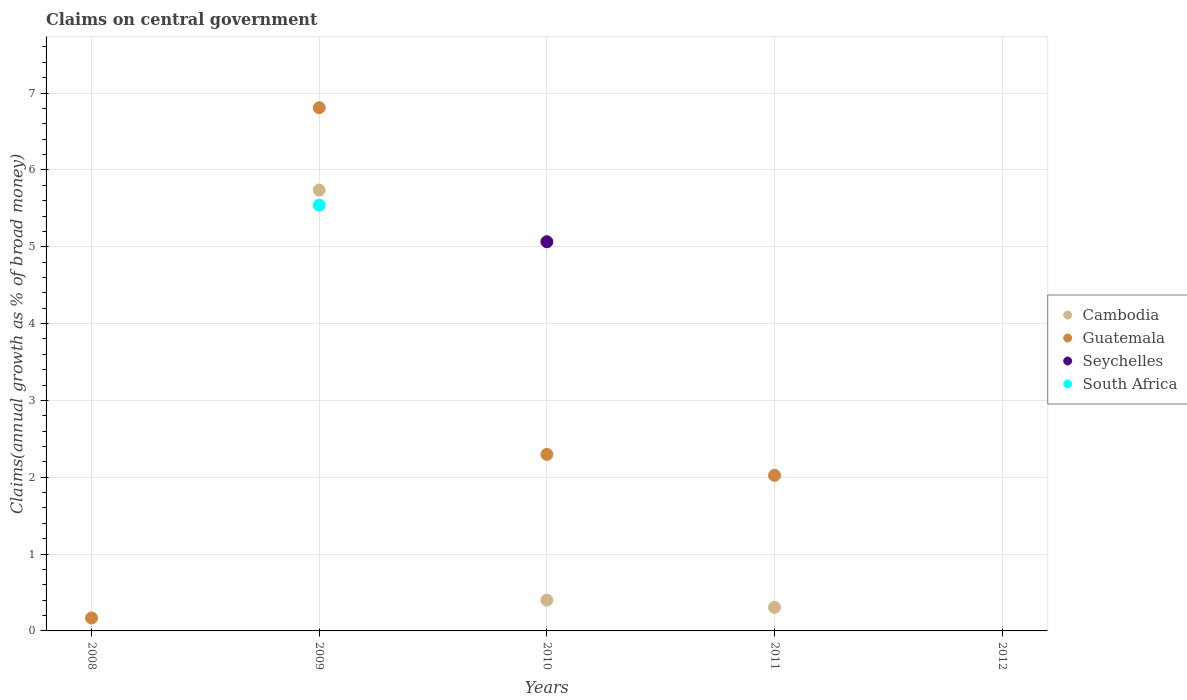How many different coloured dotlines are there?
Provide a succinct answer. 4. What is the percentage of broad money claimed on centeral government in Seychelles in 2009?
Make the answer very short. 0. Across all years, what is the maximum percentage of broad money claimed on centeral government in Guatemala?
Provide a short and direct response. 6.81. Across all years, what is the minimum percentage of broad money claimed on centeral government in South Africa?
Your response must be concise. 0. What is the total percentage of broad money claimed on centeral government in Seychelles in the graph?
Offer a very short reply. 5.07. What is the difference between the percentage of broad money claimed on centeral government in Cambodia in 2010 and that in 2011?
Your answer should be compact. 0.09. What is the difference between the percentage of broad money claimed on centeral government in Seychelles in 2011 and the percentage of broad money claimed on centeral government in Cambodia in 2012?
Provide a short and direct response. 0. What is the average percentage of broad money claimed on centeral government in Cambodia per year?
Provide a short and direct response. 1.29. In the year 2010, what is the difference between the percentage of broad money claimed on centeral government in Guatemala and percentage of broad money claimed on centeral government in Seychelles?
Provide a short and direct response. -2.77. In how many years, is the percentage of broad money claimed on centeral government in Guatemala greater than 0.2 %?
Your response must be concise. 3. What is the ratio of the percentage of broad money claimed on centeral government in Guatemala in 2009 to that in 2010?
Give a very brief answer. 2.96. What is the difference between the highest and the second highest percentage of broad money claimed on centeral government in Cambodia?
Your answer should be compact. 5.34. What is the difference between the highest and the lowest percentage of broad money claimed on centeral government in Cambodia?
Offer a very short reply. 5.74. Is it the case that in every year, the sum of the percentage of broad money claimed on centeral government in Seychelles and percentage of broad money claimed on centeral government in Guatemala  is greater than the sum of percentage of broad money claimed on centeral government in South Africa and percentage of broad money claimed on centeral government in Cambodia?
Give a very brief answer. No. Is it the case that in every year, the sum of the percentage of broad money claimed on centeral government in South Africa and percentage of broad money claimed on centeral government in Cambodia  is greater than the percentage of broad money claimed on centeral government in Seychelles?
Provide a succinct answer. No. Is the percentage of broad money claimed on centeral government in Seychelles strictly greater than the percentage of broad money claimed on centeral government in Cambodia over the years?
Keep it short and to the point. No. What is the difference between two consecutive major ticks on the Y-axis?
Your answer should be very brief. 1. Are the values on the major ticks of Y-axis written in scientific E-notation?
Your answer should be compact. No. Does the graph contain any zero values?
Provide a short and direct response. Yes. Where does the legend appear in the graph?
Your answer should be compact. Center right. How many legend labels are there?
Make the answer very short. 4. What is the title of the graph?
Provide a succinct answer. Claims on central government. What is the label or title of the Y-axis?
Ensure brevity in your answer.  Claims(annual growth as % of broad money). What is the Claims(annual growth as % of broad money) in Guatemala in 2008?
Ensure brevity in your answer.  0.17. What is the Claims(annual growth as % of broad money) of Cambodia in 2009?
Your answer should be compact. 5.74. What is the Claims(annual growth as % of broad money) in Guatemala in 2009?
Offer a terse response. 6.81. What is the Claims(annual growth as % of broad money) in Seychelles in 2009?
Provide a succinct answer. 0. What is the Claims(annual growth as % of broad money) of South Africa in 2009?
Give a very brief answer. 5.54. What is the Claims(annual growth as % of broad money) in Cambodia in 2010?
Offer a very short reply. 0.4. What is the Claims(annual growth as % of broad money) of Guatemala in 2010?
Offer a very short reply. 2.3. What is the Claims(annual growth as % of broad money) in Seychelles in 2010?
Ensure brevity in your answer.  5.07. What is the Claims(annual growth as % of broad money) in Cambodia in 2011?
Your answer should be very brief. 0.31. What is the Claims(annual growth as % of broad money) in Guatemala in 2011?
Keep it short and to the point. 2.03. What is the Claims(annual growth as % of broad money) of Seychelles in 2011?
Ensure brevity in your answer.  0. What is the Claims(annual growth as % of broad money) in Cambodia in 2012?
Give a very brief answer. 0. Across all years, what is the maximum Claims(annual growth as % of broad money) in Cambodia?
Your answer should be compact. 5.74. Across all years, what is the maximum Claims(annual growth as % of broad money) of Guatemala?
Your response must be concise. 6.81. Across all years, what is the maximum Claims(annual growth as % of broad money) of Seychelles?
Provide a short and direct response. 5.07. Across all years, what is the maximum Claims(annual growth as % of broad money) in South Africa?
Ensure brevity in your answer.  5.54. Across all years, what is the minimum Claims(annual growth as % of broad money) in Seychelles?
Offer a very short reply. 0. What is the total Claims(annual growth as % of broad money) of Cambodia in the graph?
Your answer should be compact. 6.45. What is the total Claims(annual growth as % of broad money) in Guatemala in the graph?
Your response must be concise. 11.3. What is the total Claims(annual growth as % of broad money) in Seychelles in the graph?
Your answer should be very brief. 5.07. What is the total Claims(annual growth as % of broad money) of South Africa in the graph?
Give a very brief answer. 5.54. What is the difference between the Claims(annual growth as % of broad money) in Guatemala in 2008 and that in 2009?
Give a very brief answer. -6.64. What is the difference between the Claims(annual growth as % of broad money) of Guatemala in 2008 and that in 2010?
Make the answer very short. -2.13. What is the difference between the Claims(annual growth as % of broad money) in Guatemala in 2008 and that in 2011?
Give a very brief answer. -1.86. What is the difference between the Claims(annual growth as % of broad money) in Cambodia in 2009 and that in 2010?
Your response must be concise. 5.34. What is the difference between the Claims(annual growth as % of broad money) of Guatemala in 2009 and that in 2010?
Provide a short and direct response. 4.51. What is the difference between the Claims(annual growth as % of broad money) of Cambodia in 2009 and that in 2011?
Keep it short and to the point. 5.43. What is the difference between the Claims(annual growth as % of broad money) of Guatemala in 2009 and that in 2011?
Offer a very short reply. 4.78. What is the difference between the Claims(annual growth as % of broad money) in Cambodia in 2010 and that in 2011?
Your response must be concise. 0.09. What is the difference between the Claims(annual growth as % of broad money) in Guatemala in 2010 and that in 2011?
Ensure brevity in your answer.  0.27. What is the difference between the Claims(annual growth as % of broad money) in Guatemala in 2008 and the Claims(annual growth as % of broad money) in South Africa in 2009?
Ensure brevity in your answer.  -5.37. What is the difference between the Claims(annual growth as % of broad money) in Guatemala in 2008 and the Claims(annual growth as % of broad money) in Seychelles in 2010?
Your response must be concise. -4.9. What is the difference between the Claims(annual growth as % of broad money) of Cambodia in 2009 and the Claims(annual growth as % of broad money) of Guatemala in 2010?
Give a very brief answer. 3.44. What is the difference between the Claims(annual growth as % of broad money) of Cambodia in 2009 and the Claims(annual growth as % of broad money) of Seychelles in 2010?
Ensure brevity in your answer.  0.67. What is the difference between the Claims(annual growth as % of broad money) in Guatemala in 2009 and the Claims(annual growth as % of broad money) in Seychelles in 2010?
Provide a succinct answer. 1.74. What is the difference between the Claims(annual growth as % of broad money) in Cambodia in 2009 and the Claims(annual growth as % of broad money) in Guatemala in 2011?
Give a very brief answer. 3.71. What is the difference between the Claims(annual growth as % of broad money) in Cambodia in 2010 and the Claims(annual growth as % of broad money) in Guatemala in 2011?
Give a very brief answer. -1.62. What is the average Claims(annual growth as % of broad money) of Cambodia per year?
Offer a very short reply. 1.29. What is the average Claims(annual growth as % of broad money) of Guatemala per year?
Your response must be concise. 2.26. What is the average Claims(annual growth as % of broad money) in Seychelles per year?
Make the answer very short. 1.01. What is the average Claims(annual growth as % of broad money) of South Africa per year?
Your response must be concise. 1.11. In the year 2009, what is the difference between the Claims(annual growth as % of broad money) of Cambodia and Claims(annual growth as % of broad money) of Guatemala?
Your answer should be very brief. -1.07. In the year 2009, what is the difference between the Claims(annual growth as % of broad money) of Cambodia and Claims(annual growth as % of broad money) of South Africa?
Make the answer very short. 0.2. In the year 2009, what is the difference between the Claims(annual growth as % of broad money) of Guatemala and Claims(annual growth as % of broad money) of South Africa?
Offer a terse response. 1.27. In the year 2010, what is the difference between the Claims(annual growth as % of broad money) of Cambodia and Claims(annual growth as % of broad money) of Guatemala?
Keep it short and to the point. -1.9. In the year 2010, what is the difference between the Claims(annual growth as % of broad money) of Cambodia and Claims(annual growth as % of broad money) of Seychelles?
Your answer should be compact. -4.67. In the year 2010, what is the difference between the Claims(annual growth as % of broad money) in Guatemala and Claims(annual growth as % of broad money) in Seychelles?
Ensure brevity in your answer.  -2.77. In the year 2011, what is the difference between the Claims(annual growth as % of broad money) of Cambodia and Claims(annual growth as % of broad money) of Guatemala?
Your response must be concise. -1.72. What is the ratio of the Claims(annual growth as % of broad money) in Guatemala in 2008 to that in 2009?
Provide a succinct answer. 0.02. What is the ratio of the Claims(annual growth as % of broad money) of Guatemala in 2008 to that in 2010?
Provide a succinct answer. 0.07. What is the ratio of the Claims(annual growth as % of broad money) of Guatemala in 2008 to that in 2011?
Ensure brevity in your answer.  0.08. What is the ratio of the Claims(annual growth as % of broad money) in Cambodia in 2009 to that in 2010?
Provide a short and direct response. 14.33. What is the ratio of the Claims(annual growth as % of broad money) in Guatemala in 2009 to that in 2010?
Your answer should be very brief. 2.96. What is the ratio of the Claims(annual growth as % of broad money) in Cambodia in 2009 to that in 2011?
Ensure brevity in your answer.  18.69. What is the ratio of the Claims(annual growth as % of broad money) of Guatemala in 2009 to that in 2011?
Offer a very short reply. 3.36. What is the ratio of the Claims(annual growth as % of broad money) of Cambodia in 2010 to that in 2011?
Provide a succinct answer. 1.3. What is the ratio of the Claims(annual growth as % of broad money) in Guatemala in 2010 to that in 2011?
Give a very brief answer. 1.13. What is the difference between the highest and the second highest Claims(annual growth as % of broad money) in Cambodia?
Provide a succinct answer. 5.34. What is the difference between the highest and the second highest Claims(annual growth as % of broad money) of Guatemala?
Ensure brevity in your answer.  4.51. What is the difference between the highest and the lowest Claims(annual growth as % of broad money) in Cambodia?
Your answer should be very brief. 5.74. What is the difference between the highest and the lowest Claims(annual growth as % of broad money) of Guatemala?
Offer a very short reply. 6.81. What is the difference between the highest and the lowest Claims(annual growth as % of broad money) of Seychelles?
Keep it short and to the point. 5.07. What is the difference between the highest and the lowest Claims(annual growth as % of broad money) of South Africa?
Make the answer very short. 5.54. 